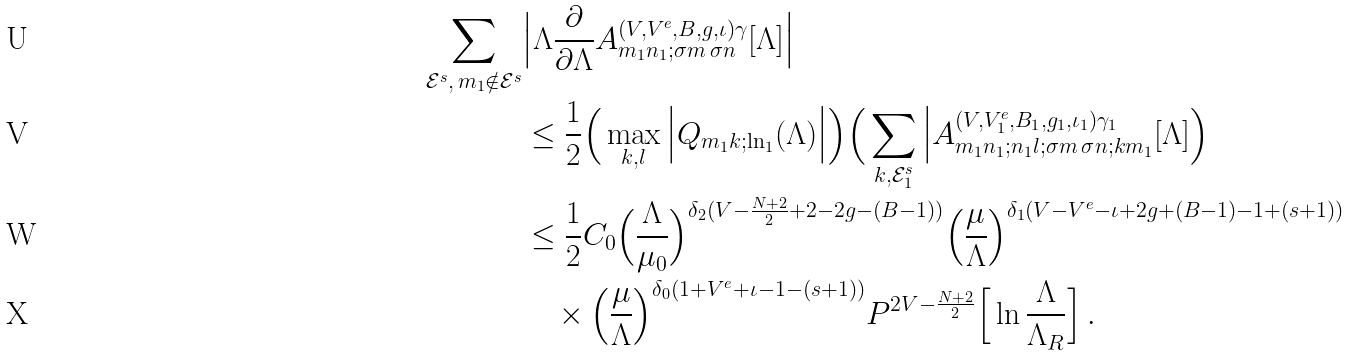<formula> <loc_0><loc_0><loc_500><loc_500>\sum _ { \mathcal { E } ^ { s } , \, m _ { 1 } \notin \mathcal { E } ^ { s } } & \Big | \Lambda \frac { \partial } { \partial \Lambda } A ^ { ( V , V ^ { e } , B , g , \iota ) \gamma } _ { m _ { 1 } n _ { 1 } ; \sigma m \, \sigma n } [ \Lambda ] \Big | \\ & \leq \frac { 1 } { 2 } \Big ( \max _ { k , l } \Big | Q _ { m _ { 1 } k ; \ln _ { 1 } } ( \Lambda ) \Big | \Big ) \Big ( \sum _ { k , \mathcal { E } _ { 1 } ^ { s } } \Big | A ^ { ( V , V ^ { e } _ { 1 } , B _ { 1 } , g _ { 1 } , \iota _ { 1 } ) \gamma _ { 1 } } _ { m _ { 1 } n _ { 1 } ; n _ { 1 } l ; \sigma m \, \sigma n ; k m _ { 1 } } [ \Lambda ] \Big ) \\ & \leq \frac { 1 } { 2 } C _ { 0 } \Big ( \frac { \Lambda } { \mu _ { 0 } } \Big ) ^ { \delta _ { 2 } ( V - \frac { N + 2 } { 2 } + 2 - 2 g - ( B - 1 ) ) } \Big ( \frac { \mu } { \Lambda } \Big ) ^ { \delta _ { 1 } ( V - V ^ { e } - \iota + 2 g + ( B - 1 ) - 1 + ( s + 1 ) ) } \\ & \quad \times \Big ( \frac { \mu } { \Lambda } \Big ) ^ { \delta _ { 0 } ( 1 + V ^ { e } + \iota - 1 - ( s + 1 ) ) } P ^ { 2 V - \frac { N + 2 } { 2 } } \Big [ \ln \frac { \Lambda } { \Lambda _ { R } } \Big ] \, .</formula> 